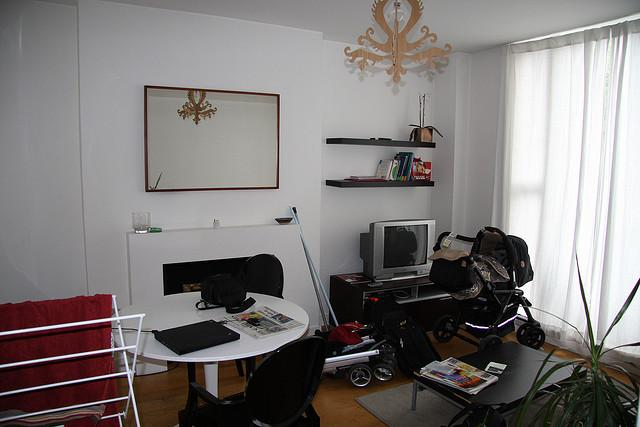Which object in the room is the most mobile?

Choices:
A) baby carriage
B) table
C) mirror
D) television baby carriage 